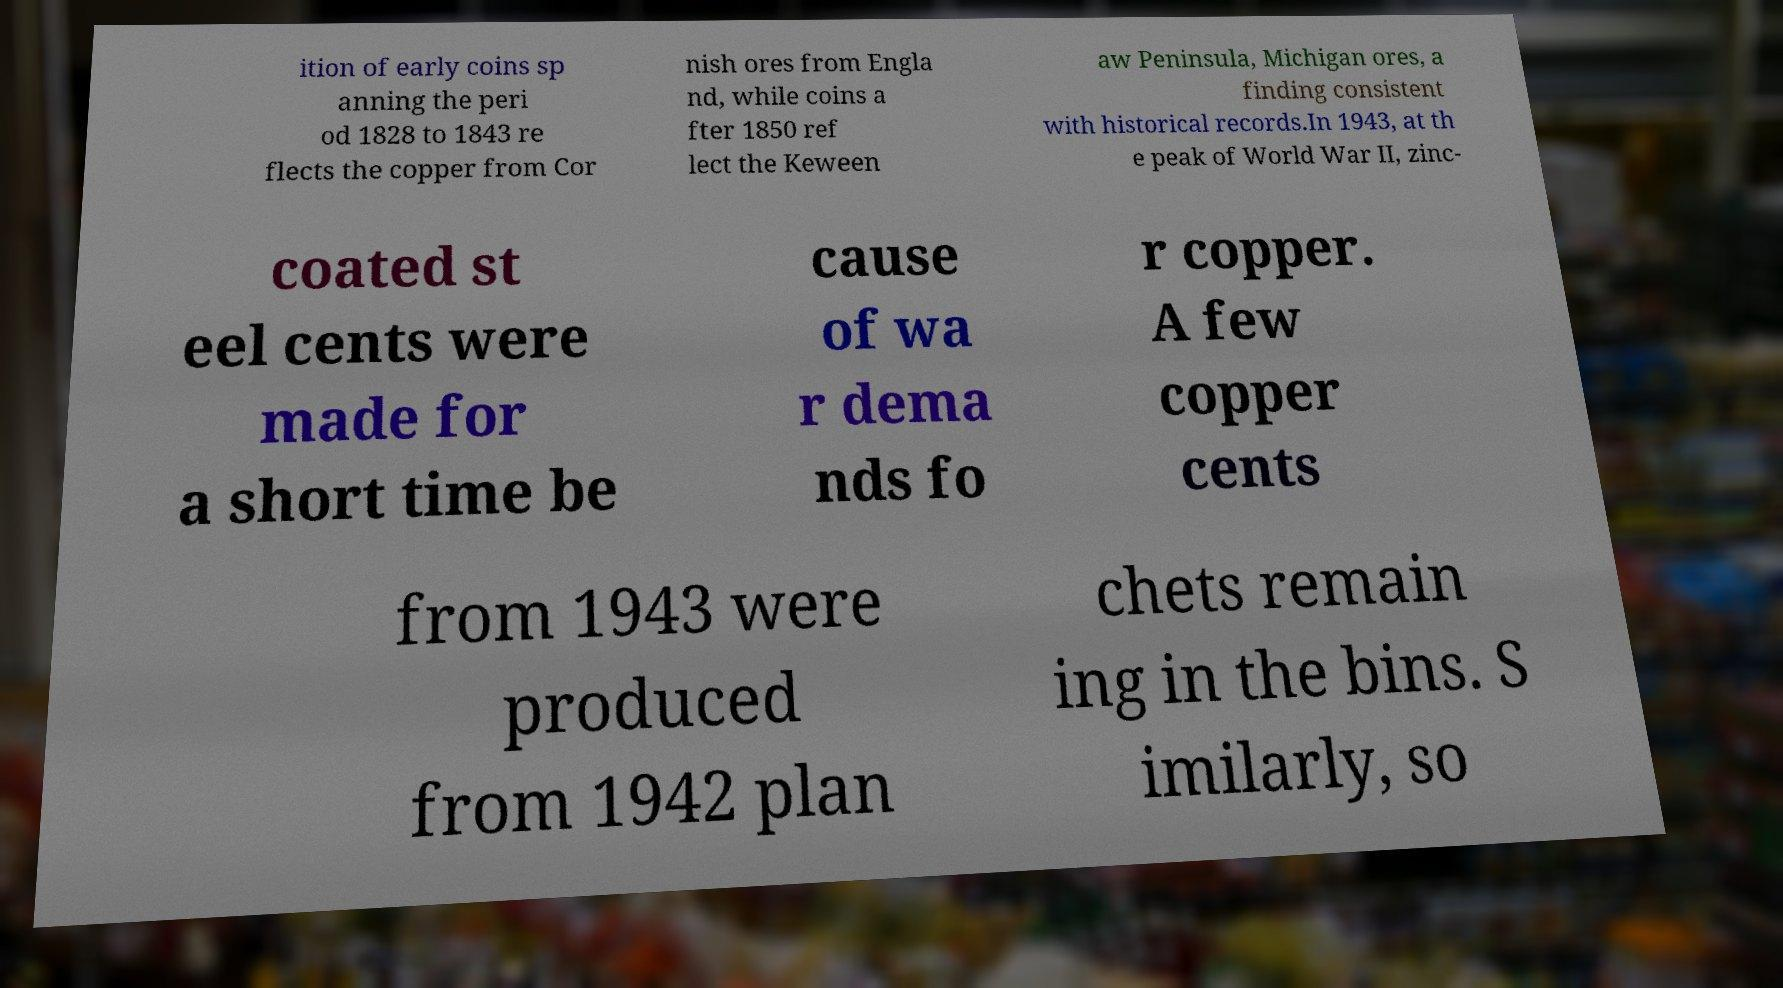Can you read and provide the text displayed in the image?This photo seems to have some interesting text. Can you extract and type it out for me? ition of early coins sp anning the peri od 1828 to 1843 re flects the copper from Cor nish ores from Engla nd, while coins a fter 1850 ref lect the Keween aw Peninsula, Michigan ores, a finding consistent with historical records.In 1943, at th e peak of World War II, zinc- coated st eel cents were made for a short time be cause of wa r dema nds fo r copper. A few copper cents from 1943 were produced from 1942 plan chets remain ing in the bins. S imilarly, so 